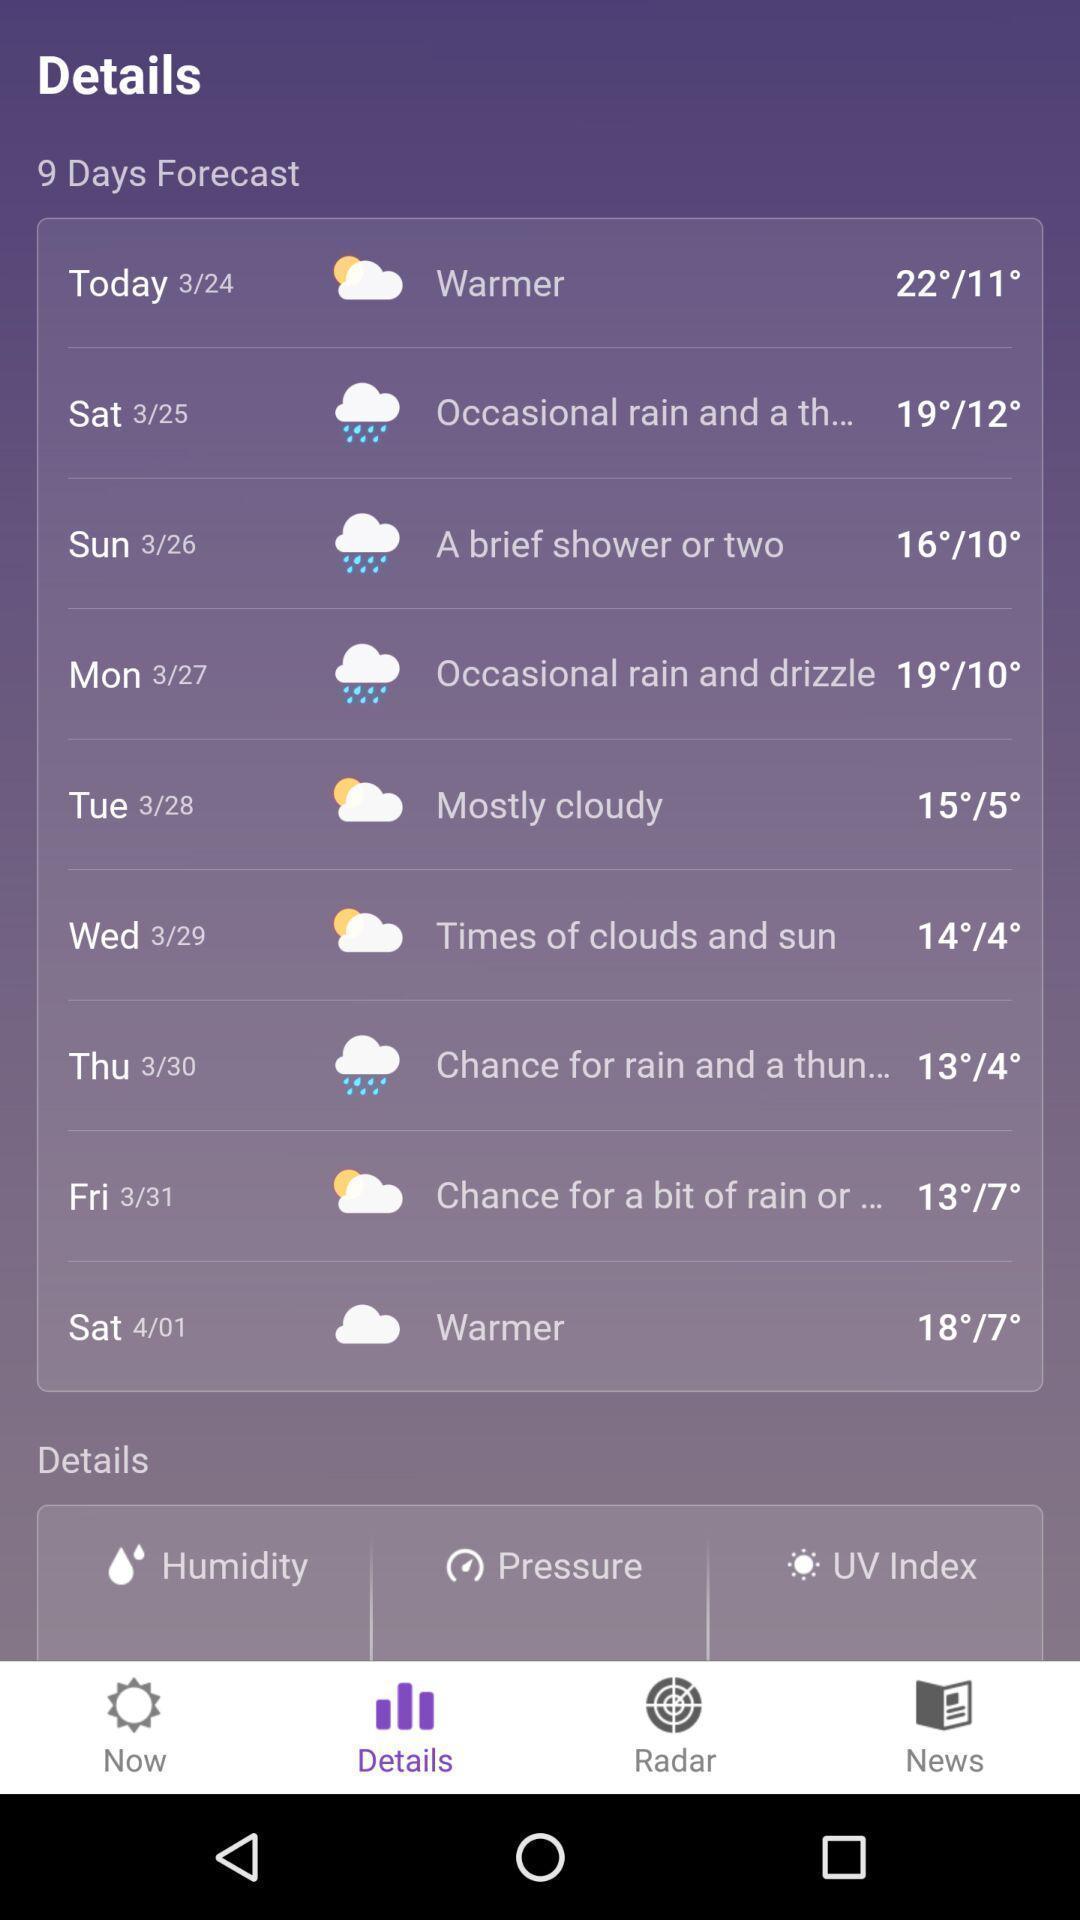Explain the elements present in this screenshot. Weather details displaying in this page. 